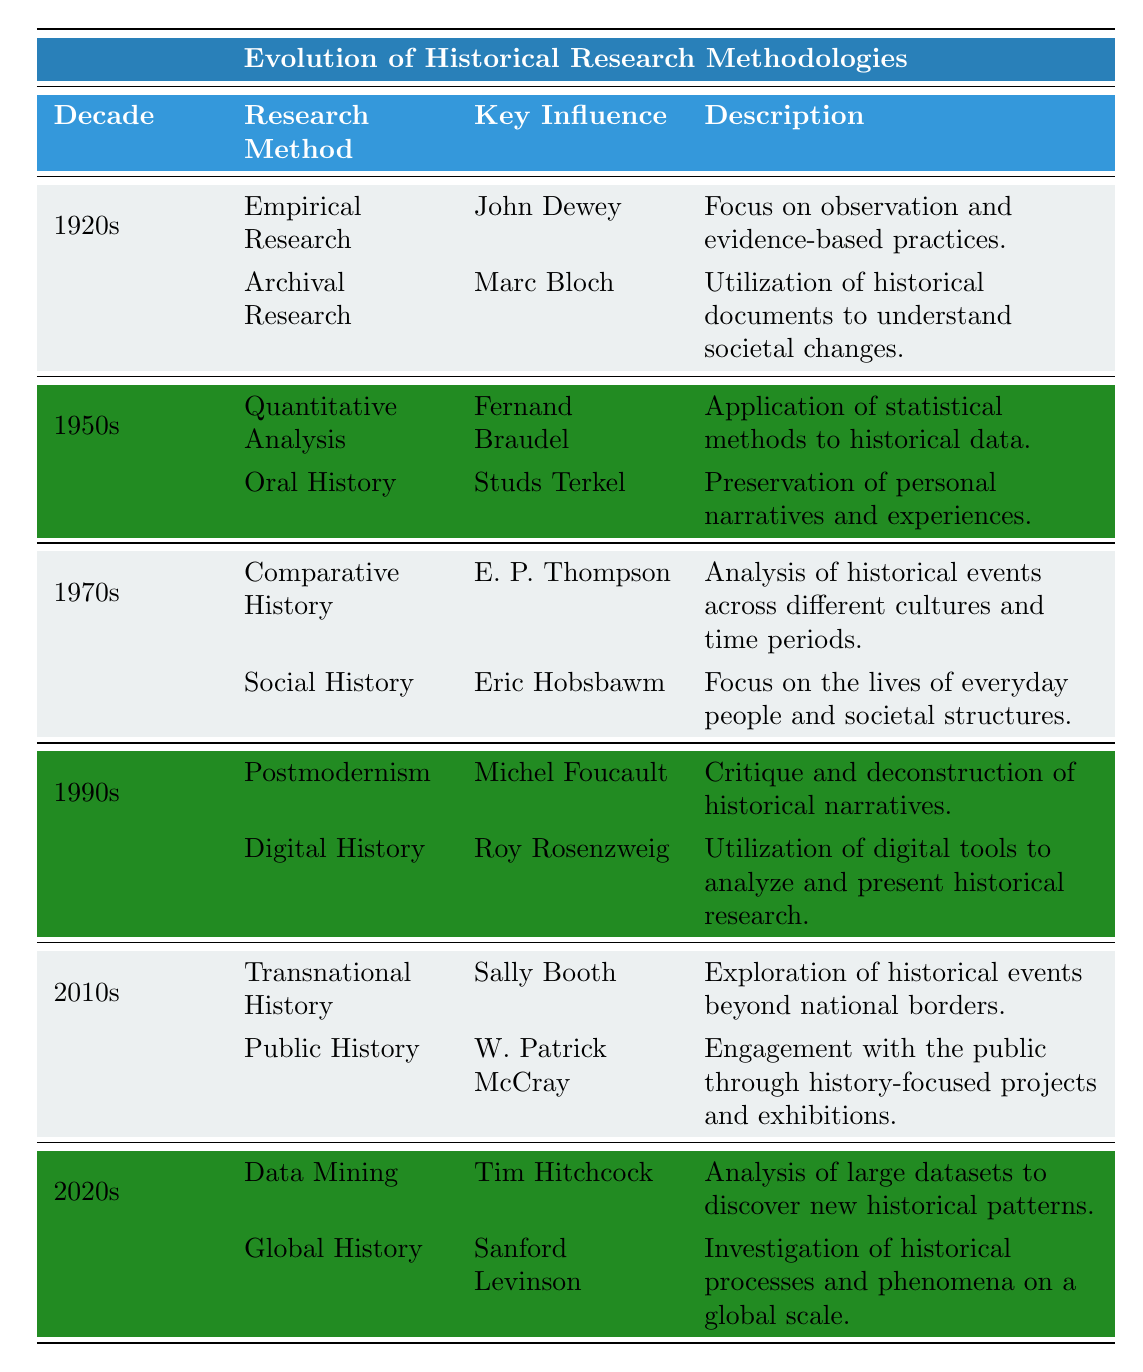What research method in the 1920s was influenced by John Dewey? In the 1920s section of the table, the research method associated with John Dewey is "Empirical Research."
Answer: Empirical Research Which decade introduced "Quantitative Analysis"? The table shows that "Quantitative Analysis" was introduced in the 1950s.
Answer: 1950s How many research methodologies are listed for the 1970s? There are two methodologies listed for the 1970s: "Comparative History" and "Social History."
Answer: 2 Is "Digital History" mentioned as a methodology in the 1990s? Yes, "Digital History" is indeed one of the methodologies listed for the 1990s.
Answer: Yes In which decade did "Postmodernism" gain prominence? The table indicates that "Postmodernism" became prominent in the 1990s.
Answer: 1990s Who influenced the methodology of "Oral History"? According to the table, the key influence for "Oral History" is Studs Terkel.
Answer: Studs Terkel What methodological shift is observed from the 1920s to the 2010s? The shift can be seen by moving from traditional empirical and archival research in the 1920s to more inclusive methodologies like "Transnational History" and "Public History" in the 2010s, which consider global perspectives and public engagement.
Answer: A shift towards inclusivity and global perspectives Identify a methodology from the 2020s and explain its focus. The methodology "Data Mining," influenced by Tim Hitchcock, focuses on analyzing large datasets to uncover new historical patterns. The table specifies this.
Answer: Data Mining What trend can be seen regarding the key influences on research methodologies over the decades? An observable trend is the movement from individual thinkers in the earlier decades, like John Dewey and Marc Bloch, to more diverse influences, including groups focused on data and globalization in the 2020s, suggesting a broader approach to historical research.
Answer: Trend towards diverse influences and global perspectives In which decade was "Social History" prominent, and who was its key influence? "Social History" was prominent in the 1970s, and its key influence was Eric Hobsbawm.
Answer: 1970s, Eric Hobsbawm 